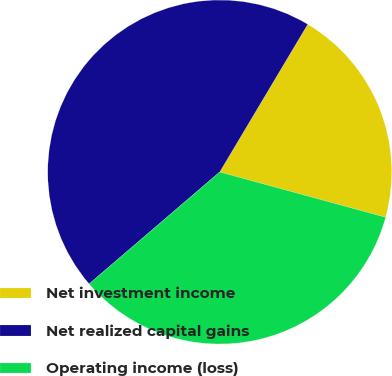Convert chart to OTSL. <chart><loc_0><loc_0><loc_500><loc_500><pie_chart><fcel>Net investment income<fcel>Net realized capital gains<fcel>Operating income (loss)<nl><fcel>20.69%<fcel>44.83%<fcel>34.48%<nl></chart> 